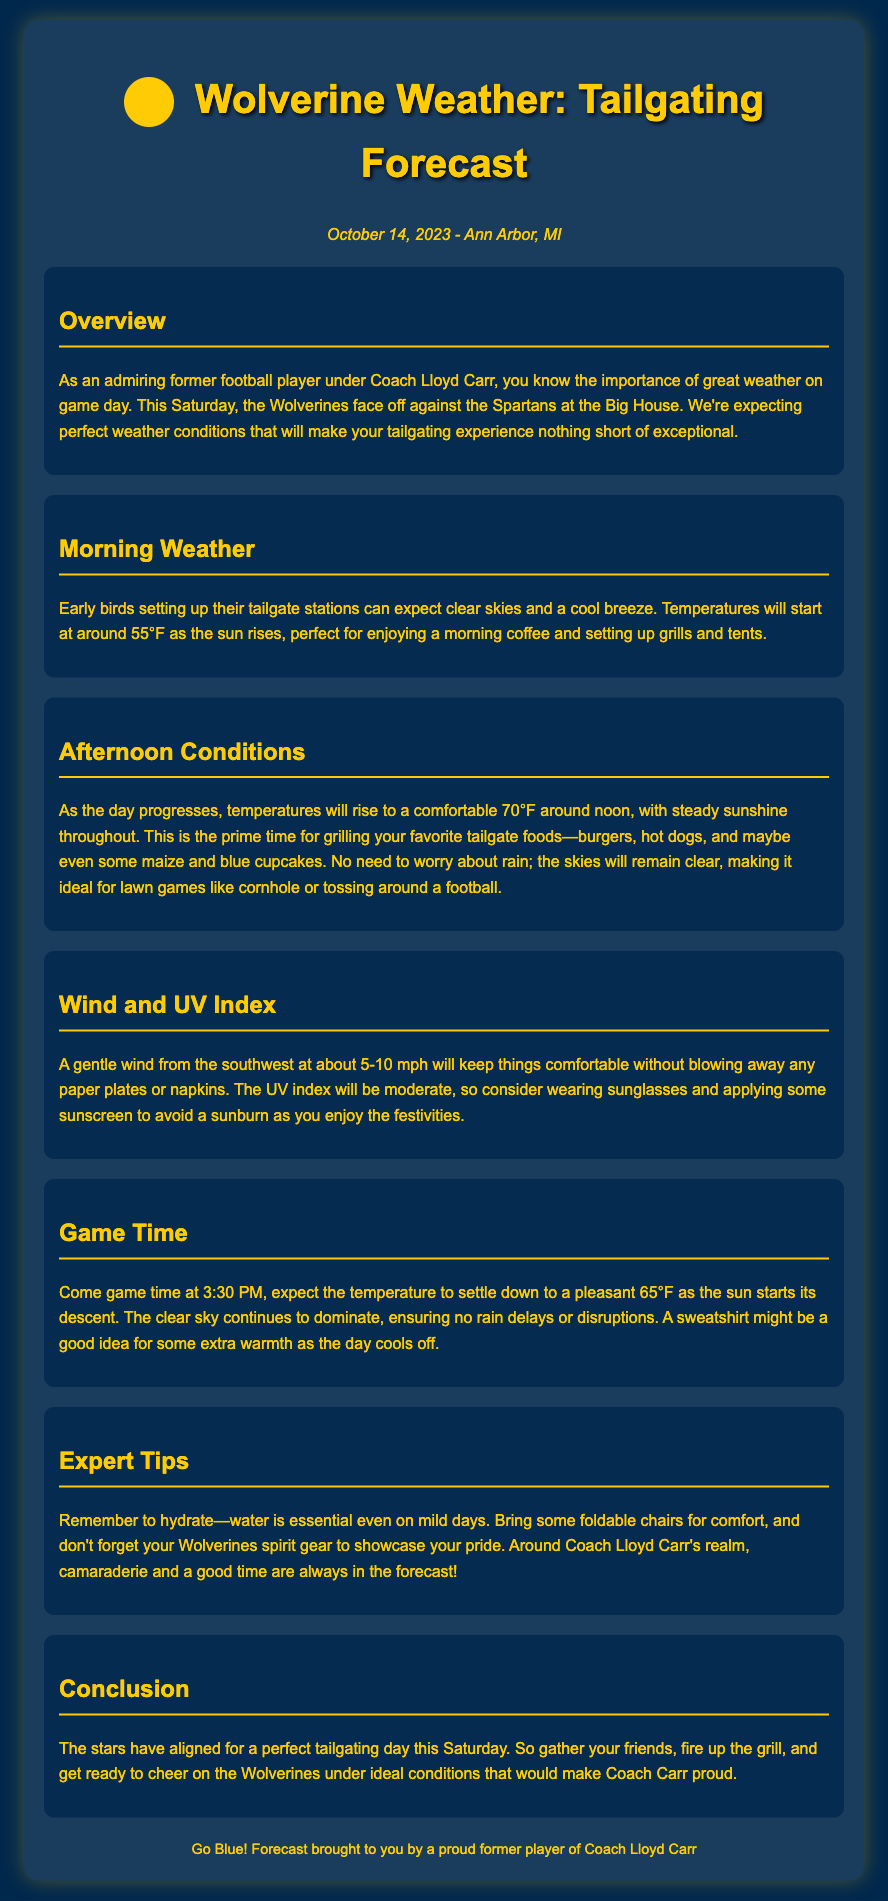What is the date of the weather report? The date of the weather report is mentioned in the document, which is specifically stated at the beginning.
Answer: October 14, 2023 What is the expected morning temperature? The expected morning temperature is outlined in the section about morning weather, providing specific temperature details for the morning.
Answer: 55°F What will the afternoon temperature rise to? The afternoon conditions provide a temperature that will be reached as the day progresses.
Answer: 70°F What is the wind speed described in the report? The section discussing wind and UV index mentions the wind speed expected during the tailgating event.
Answer: 5-10 mph What time is the game scheduled to start? The game time is explicitly provided in the section dedicated to the game timing.
Answer: 3:30 PM What should you consider wearing due to the UV index? In the section about wind and UV index, it suggests actions based on the UV index to avoid sunburn.
Answer: Sunglasses What is a recommended item to bring for comfort? The expert tips section provides some suggestions for what to bring to enhance the tailgating experience.
Answer: Foldable chairs What kind of weather is expected during the game? The section for game time highlights the weather conditions expected at that time and mentions specific aspects of it.
Answer: Clear sky What does the conclusion suggest you do with your friends? The conclusion encourages a social activity among friends during the game day.
Answer: Gather and cheer 